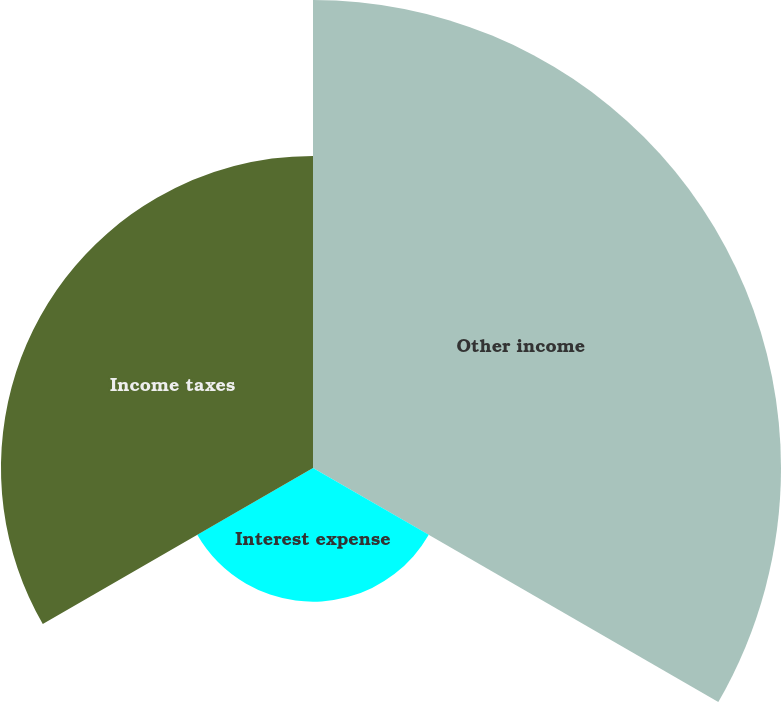Convert chart to OTSL. <chart><loc_0><loc_0><loc_500><loc_500><pie_chart><fcel>Other income<fcel>Interest expense<fcel>Income taxes<nl><fcel>51.22%<fcel>14.63%<fcel>34.15%<nl></chart> 